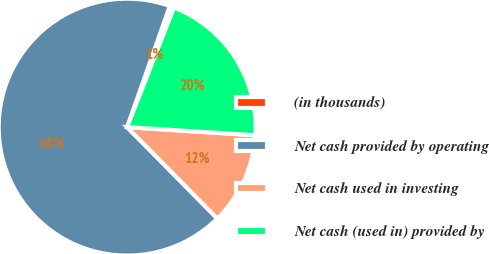Convert chart to OTSL. <chart><loc_0><loc_0><loc_500><loc_500><pie_chart><fcel>(in thousands)<fcel>Net cash provided by operating<fcel>Net cash used in investing<fcel>Net cash (used in) provided by<nl><fcel>0.55%<fcel>67.79%<fcel>11.59%<fcel>20.07%<nl></chart> 